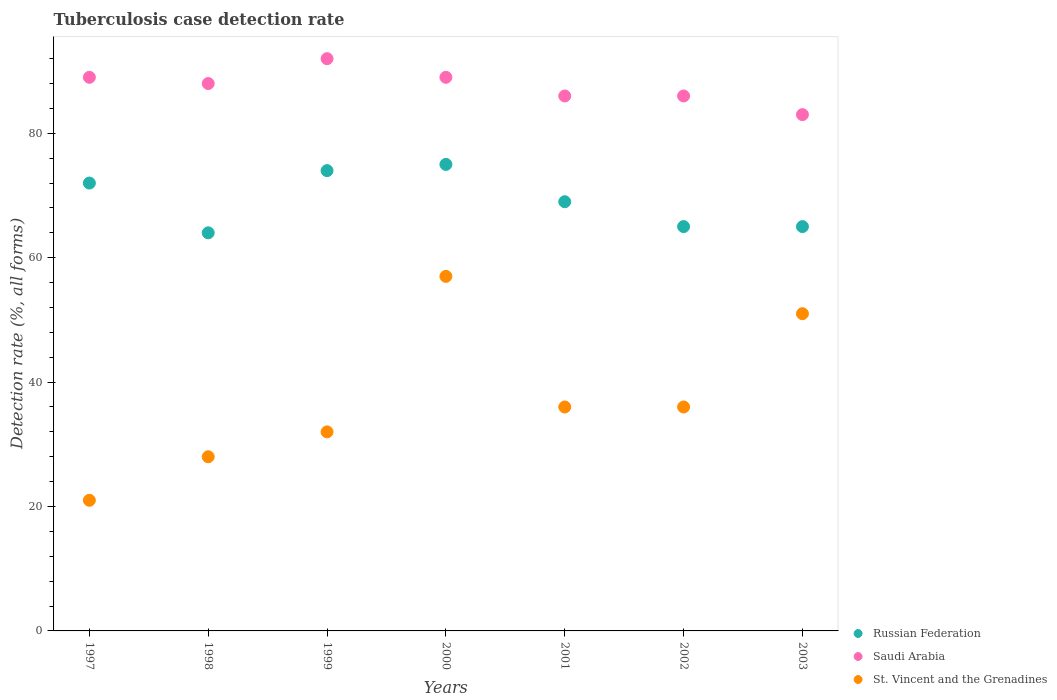Is the number of dotlines equal to the number of legend labels?
Offer a very short reply. Yes. What is the tuberculosis case detection rate in in Saudi Arabia in 2002?
Provide a short and direct response. 86. Across all years, what is the maximum tuberculosis case detection rate in in Saudi Arabia?
Your answer should be very brief. 92. Across all years, what is the minimum tuberculosis case detection rate in in Russian Federation?
Your answer should be compact. 64. In which year was the tuberculosis case detection rate in in Saudi Arabia maximum?
Make the answer very short. 1999. In which year was the tuberculosis case detection rate in in Saudi Arabia minimum?
Give a very brief answer. 2003. What is the total tuberculosis case detection rate in in St. Vincent and the Grenadines in the graph?
Give a very brief answer. 261. What is the average tuberculosis case detection rate in in Russian Federation per year?
Provide a short and direct response. 69.14. What is the ratio of the tuberculosis case detection rate in in Saudi Arabia in 1997 to that in 2003?
Provide a succinct answer. 1.07. Is the tuberculosis case detection rate in in St. Vincent and the Grenadines in 1997 less than that in 2003?
Your response must be concise. Yes. Is the sum of the tuberculosis case detection rate in in Saudi Arabia in 1998 and 2002 greater than the maximum tuberculosis case detection rate in in Russian Federation across all years?
Your answer should be very brief. Yes. Is it the case that in every year, the sum of the tuberculosis case detection rate in in Russian Federation and tuberculosis case detection rate in in Saudi Arabia  is greater than the tuberculosis case detection rate in in St. Vincent and the Grenadines?
Offer a very short reply. Yes. Does the tuberculosis case detection rate in in Saudi Arabia monotonically increase over the years?
Ensure brevity in your answer.  No. Is the tuberculosis case detection rate in in St. Vincent and the Grenadines strictly less than the tuberculosis case detection rate in in Russian Federation over the years?
Make the answer very short. Yes. How many dotlines are there?
Offer a very short reply. 3. How many years are there in the graph?
Ensure brevity in your answer.  7. What is the difference between two consecutive major ticks on the Y-axis?
Keep it short and to the point. 20. How many legend labels are there?
Offer a very short reply. 3. What is the title of the graph?
Offer a very short reply. Tuberculosis case detection rate. What is the label or title of the X-axis?
Your response must be concise. Years. What is the label or title of the Y-axis?
Provide a succinct answer. Detection rate (%, all forms). What is the Detection rate (%, all forms) of Russian Federation in 1997?
Provide a short and direct response. 72. What is the Detection rate (%, all forms) of Saudi Arabia in 1997?
Your answer should be very brief. 89. What is the Detection rate (%, all forms) in St. Vincent and the Grenadines in 1997?
Keep it short and to the point. 21. What is the Detection rate (%, all forms) in Russian Federation in 1998?
Make the answer very short. 64. What is the Detection rate (%, all forms) of Saudi Arabia in 1998?
Your answer should be compact. 88. What is the Detection rate (%, all forms) of St. Vincent and the Grenadines in 1998?
Your answer should be compact. 28. What is the Detection rate (%, all forms) of Saudi Arabia in 1999?
Provide a succinct answer. 92. What is the Detection rate (%, all forms) in St. Vincent and the Grenadines in 1999?
Your answer should be very brief. 32. What is the Detection rate (%, all forms) in Russian Federation in 2000?
Provide a succinct answer. 75. What is the Detection rate (%, all forms) in Saudi Arabia in 2000?
Ensure brevity in your answer.  89. What is the Detection rate (%, all forms) in St. Vincent and the Grenadines in 2001?
Offer a very short reply. 36. What is the Detection rate (%, all forms) in Saudi Arabia in 2002?
Your answer should be compact. 86. What is the Detection rate (%, all forms) of Russian Federation in 2003?
Ensure brevity in your answer.  65. What is the Detection rate (%, all forms) of Saudi Arabia in 2003?
Provide a short and direct response. 83. Across all years, what is the maximum Detection rate (%, all forms) in Saudi Arabia?
Offer a terse response. 92. What is the total Detection rate (%, all forms) of Russian Federation in the graph?
Your answer should be compact. 484. What is the total Detection rate (%, all forms) in Saudi Arabia in the graph?
Provide a succinct answer. 613. What is the total Detection rate (%, all forms) in St. Vincent and the Grenadines in the graph?
Give a very brief answer. 261. What is the difference between the Detection rate (%, all forms) in St. Vincent and the Grenadines in 1997 and that in 1998?
Make the answer very short. -7. What is the difference between the Detection rate (%, all forms) in Saudi Arabia in 1997 and that in 1999?
Provide a succinct answer. -3. What is the difference between the Detection rate (%, all forms) of St. Vincent and the Grenadines in 1997 and that in 1999?
Offer a terse response. -11. What is the difference between the Detection rate (%, all forms) in Russian Federation in 1997 and that in 2000?
Offer a terse response. -3. What is the difference between the Detection rate (%, all forms) of St. Vincent and the Grenadines in 1997 and that in 2000?
Offer a very short reply. -36. What is the difference between the Detection rate (%, all forms) in Russian Federation in 1997 and that in 2001?
Ensure brevity in your answer.  3. What is the difference between the Detection rate (%, all forms) of St. Vincent and the Grenadines in 1997 and that in 2001?
Offer a very short reply. -15. What is the difference between the Detection rate (%, all forms) in Russian Federation in 1997 and that in 2002?
Your response must be concise. 7. What is the difference between the Detection rate (%, all forms) of Saudi Arabia in 1997 and that in 2002?
Your answer should be compact. 3. What is the difference between the Detection rate (%, all forms) in St. Vincent and the Grenadines in 1997 and that in 2002?
Give a very brief answer. -15. What is the difference between the Detection rate (%, all forms) in Russian Federation in 1997 and that in 2003?
Give a very brief answer. 7. What is the difference between the Detection rate (%, all forms) of St. Vincent and the Grenadines in 1997 and that in 2003?
Ensure brevity in your answer.  -30. What is the difference between the Detection rate (%, all forms) in St. Vincent and the Grenadines in 1998 and that in 1999?
Keep it short and to the point. -4. What is the difference between the Detection rate (%, all forms) in Russian Federation in 1998 and that in 2000?
Your answer should be compact. -11. What is the difference between the Detection rate (%, all forms) in St. Vincent and the Grenadines in 1998 and that in 2000?
Your answer should be compact. -29. What is the difference between the Detection rate (%, all forms) of Russian Federation in 1998 and that in 2002?
Your answer should be very brief. -1. What is the difference between the Detection rate (%, all forms) of St. Vincent and the Grenadines in 1998 and that in 2002?
Make the answer very short. -8. What is the difference between the Detection rate (%, all forms) in Russian Federation in 1998 and that in 2003?
Ensure brevity in your answer.  -1. What is the difference between the Detection rate (%, all forms) in St. Vincent and the Grenadines in 1999 and that in 2000?
Keep it short and to the point. -25. What is the difference between the Detection rate (%, all forms) in Russian Federation in 1999 and that in 2001?
Your answer should be compact. 5. What is the difference between the Detection rate (%, all forms) in Saudi Arabia in 1999 and that in 2001?
Provide a succinct answer. 6. What is the difference between the Detection rate (%, all forms) in St. Vincent and the Grenadines in 1999 and that in 2001?
Ensure brevity in your answer.  -4. What is the difference between the Detection rate (%, all forms) of Russian Federation in 1999 and that in 2002?
Your answer should be very brief. 9. What is the difference between the Detection rate (%, all forms) in St. Vincent and the Grenadines in 1999 and that in 2003?
Provide a short and direct response. -19. What is the difference between the Detection rate (%, all forms) of Saudi Arabia in 2000 and that in 2001?
Offer a very short reply. 3. What is the difference between the Detection rate (%, all forms) in Russian Federation in 2001 and that in 2002?
Give a very brief answer. 4. What is the difference between the Detection rate (%, all forms) in Russian Federation in 2002 and that in 2003?
Give a very brief answer. 0. What is the difference between the Detection rate (%, all forms) in Russian Federation in 1997 and the Detection rate (%, all forms) in St. Vincent and the Grenadines in 1998?
Keep it short and to the point. 44. What is the difference between the Detection rate (%, all forms) in Saudi Arabia in 1997 and the Detection rate (%, all forms) in St. Vincent and the Grenadines in 1998?
Provide a succinct answer. 61. What is the difference between the Detection rate (%, all forms) in Russian Federation in 1997 and the Detection rate (%, all forms) in St. Vincent and the Grenadines in 1999?
Offer a terse response. 40. What is the difference between the Detection rate (%, all forms) of Saudi Arabia in 1997 and the Detection rate (%, all forms) of St. Vincent and the Grenadines in 2000?
Offer a very short reply. 32. What is the difference between the Detection rate (%, all forms) of Russian Federation in 1997 and the Detection rate (%, all forms) of Saudi Arabia in 2001?
Make the answer very short. -14. What is the difference between the Detection rate (%, all forms) in Saudi Arabia in 1997 and the Detection rate (%, all forms) in St. Vincent and the Grenadines in 2001?
Make the answer very short. 53. What is the difference between the Detection rate (%, all forms) in Saudi Arabia in 1997 and the Detection rate (%, all forms) in St. Vincent and the Grenadines in 2002?
Provide a short and direct response. 53. What is the difference between the Detection rate (%, all forms) of Russian Federation in 1997 and the Detection rate (%, all forms) of Saudi Arabia in 2003?
Offer a very short reply. -11. What is the difference between the Detection rate (%, all forms) in Russian Federation in 1997 and the Detection rate (%, all forms) in St. Vincent and the Grenadines in 2003?
Offer a very short reply. 21. What is the difference between the Detection rate (%, all forms) in Russian Federation in 1998 and the Detection rate (%, all forms) in Saudi Arabia in 1999?
Provide a succinct answer. -28. What is the difference between the Detection rate (%, all forms) in Russian Federation in 1998 and the Detection rate (%, all forms) in St. Vincent and the Grenadines in 2000?
Offer a very short reply. 7. What is the difference between the Detection rate (%, all forms) of Russian Federation in 1998 and the Detection rate (%, all forms) of St. Vincent and the Grenadines in 2001?
Give a very brief answer. 28. What is the difference between the Detection rate (%, all forms) of Saudi Arabia in 1998 and the Detection rate (%, all forms) of St. Vincent and the Grenadines in 2001?
Your response must be concise. 52. What is the difference between the Detection rate (%, all forms) in Russian Federation in 1998 and the Detection rate (%, all forms) in St. Vincent and the Grenadines in 2002?
Provide a short and direct response. 28. What is the difference between the Detection rate (%, all forms) in Saudi Arabia in 1998 and the Detection rate (%, all forms) in St. Vincent and the Grenadines in 2002?
Keep it short and to the point. 52. What is the difference between the Detection rate (%, all forms) of Saudi Arabia in 1998 and the Detection rate (%, all forms) of St. Vincent and the Grenadines in 2003?
Ensure brevity in your answer.  37. What is the difference between the Detection rate (%, all forms) in Russian Federation in 1999 and the Detection rate (%, all forms) in St. Vincent and the Grenadines in 2000?
Offer a very short reply. 17. What is the difference between the Detection rate (%, all forms) in Saudi Arabia in 1999 and the Detection rate (%, all forms) in St. Vincent and the Grenadines in 2001?
Make the answer very short. 56. What is the difference between the Detection rate (%, all forms) in Russian Federation in 1999 and the Detection rate (%, all forms) in Saudi Arabia in 2002?
Provide a short and direct response. -12. What is the difference between the Detection rate (%, all forms) of Russian Federation in 1999 and the Detection rate (%, all forms) of Saudi Arabia in 2003?
Keep it short and to the point. -9. What is the difference between the Detection rate (%, all forms) in Russian Federation in 1999 and the Detection rate (%, all forms) in St. Vincent and the Grenadines in 2003?
Ensure brevity in your answer.  23. What is the difference between the Detection rate (%, all forms) in Saudi Arabia in 1999 and the Detection rate (%, all forms) in St. Vincent and the Grenadines in 2003?
Provide a succinct answer. 41. What is the difference between the Detection rate (%, all forms) in Russian Federation in 2000 and the Detection rate (%, all forms) in Saudi Arabia in 2001?
Your response must be concise. -11. What is the difference between the Detection rate (%, all forms) of Russian Federation in 2000 and the Detection rate (%, all forms) of Saudi Arabia in 2002?
Keep it short and to the point. -11. What is the difference between the Detection rate (%, all forms) in Russian Federation in 2000 and the Detection rate (%, all forms) in Saudi Arabia in 2003?
Your answer should be compact. -8. What is the difference between the Detection rate (%, all forms) in Russian Federation in 2000 and the Detection rate (%, all forms) in St. Vincent and the Grenadines in 2003?
Keep it short and to the point. 24. What is the difference between the Detection rate (%, all forms) of Saudi Arabia in 2000 and the Detection rate (%, all forms) of St. Vincent and the Grenadines in 2003?
Make the answer very short. 38. What is the difference between the Detection rate (%, all forms) of Russian Federation in 2001 and the Detection rate (%, all forms) of Saudi Arabia in 2002?
Give a very brief answer. -17. What is the difference between the Detection rate (%, all forms) in Saudi Arabia in 2001 and the Detection rate (%, all forms) in St. Vincent and the Grenadines in 2002?
Offer a terse response. 50. What is the difference between the Detection rate (%, all forms) in Russian Federation in 2001 and the Detection rate (%, all forms) in Saudi Arabia in 2003?
Keep it short and to the point. -14. What is the difference between the Detection rate (%, all forms) of Russian Federation in 2001 and the Detection rate (%, all forms) of St. Vincent and the Grenadines in 2003?
Give a very brief answer. 18. What is the difference between the Detection rate (%, all forms) in Russian Federation in 2002 and the Detection rate (%, all forms) in Saudi Arabia in 2003?
Offer a terse response. -18. What is the difference between the Detection rate (%, all forms) in Russian Federation in 2002 and the Detection rate (%, all forms) in St. Vincent and the Grenadines in 2003?
Provide a short and direct response. 14. What is the average Detection rate (%, all forms) in Russian Federation per year?
Provide a short and direct response. 69.14. What is the average Detection rate (%, all forms) of Saudi Arabia per year?
Offer a very short reply. 87.57. What is the average Detection rate (%, all forms) of St. Vincent and the Grenadines per year?
Ensure brevity in your answer.  37.29. In the year 1997, what is the difference between the Detection rate (%, all forms) of Russian Federation and Detection rate (%, all forms) of St. Vincent and the Grenadines?
Provide a succinct answer. 51. In the year 1997, what is the difference between the Detection rate (%, all forms) of Saudi Arabia and Detection rate (%, all forms) of St. Vincent and the Grenadines?
Make the answer very short. 68. In the year 1999, what is the difference between the Detection rate (%, all forms) of Russian Federation and Detection rate (%, all forms) of Saudi Arabia?
Keep it short and to the point. -18. In the year 2000, what is the difference between the Detection rate (%, all forms) in Russian Federation and Detection rate (%, all forms) in Saudi Arabia?
Make the answer very short. -14. In the year 2000, what is the difference between the Detection rate (%, all forms) of Russian Federation and Detection rate (%, all forms) of St. Vincent and the Grenadines?
Your answer should be compact. 18. In the year 2001, what is the difference between the Detection rate (%, all forms) of Russian Federation and Detection rate (%, all forms) of Saudi Arabia?
Offer a very short reply. -17. In the year 2001, what is the difference between the Detection rate (%, all forms) in Russian Federation and Detection rate (%, all forms) in St. Vincent and the Grenadines?
Ensure brevity in your answer.  33. In the year 2001, what is the difference between the Detection rate (%, all forms) of Saudi Arabia and Detection rate (%, all forms) of St. Vincent and the Grenadines?
Your response must be concise. 50. In the year 2002, what is the difference between the Detection rate (%, all forms) in Russian Federation and Detection rate (%, all forms) in Saudi Arabia?
Keep it short and to the point. -21. In the year 2002, what is the difference between the Detection rate (%, all forms) in Saudi Arabia and Detection rate (%, all forms) in St. Vincent and the Grenadines?
Your answer should be compact. 50. In the year 2003, what is the difference between the Detection rate (%, all forms) of Russian Federation and Detection rate (%, all forms) of St. Vincent and the Grenadines?
Make the answer very short. 14. What is the ratio of the Detection rate (%, all forms) in Saudi Arabia in 1997 to that in 1998?
Make the answer very short. 1.01. What is the ratio of the Detection rate (%, all forms) in St. Vincent and the Grenadines in 1997 to that in 1998?
Offer a terse response. 0.75. What is the ratio of the Detection rate (%, all forms) in Saudi Arabia in 1997 to that in 1999?
Provide a short and direct response. 0.97. What is the ratio of the Detection rate (%, all forms) of St. Vincent and the Grenadines in 1997 to that in 1999?
Offer a terse response. 0.66. What is the ratio of the Detection rate (%, all forms) of Russian Federation in 1997 to that in 2000?
Give a very brief answer. 0.96. What is the ratio of the Detection rate (%, all forms) of St. Vincent and the Grenadines in 1997 to that in 2000?
Offer a terse response. 0.37. What is the ratio of the Detection rate (%, all forms) of Russian Federation in 1997 to that in 2001?
Provide a succinct answer. 1.04. What is the ratio of the Detection rate (%, all forms) of Saudi Arabia in 1997 to that in 2001?
Your response must be concise. 1.03. What is the ratio of the Detection rate (%, all forms) in St. Vincent and the Grenadines in 1997 to that in 2001?
Your answer should be very brief. 0.58. What is the ratio of the Detection rate (%, all forms) in Russian Federation in 1997 to that in 2002?
Make the answer very short. 1.11. What is the ratio of the Detection rate (%, all forms) in Saudi Arabia in 1997 to that in 2002?
Provide a succinct answer. 1.03. What is the ratio of the Detection rate (%, all forms) of St. Vincent and the Grenadines in 1997 to that in 2002?
Your answer should be very brief. 0.58. What is the ratio of the Detection rate (%, all forms) of Russian Federation in 1997 to that in 2003?
Provide a succinct answer. 1.11. What is the ratio of the Detection rate (%, all forms) in Saudi Arabia in 1997 to that in 2003?
Provide a succinct answer. 1.07. What is the ratio of the Detection rate (%, all forms) of St. Vincent and the Grenadines in 1997 to that in 2003?
Offer a very short reply. 0.41. What is the ratio of the Detection rate (%, all forms) of Russian Federation in 1998 to that in 1999?
Ensure brevity in your answer.  0.86. What is the ratio of the Detection rate (%, all forms) of Saudi Arabia in 1998 to that in 1999?
Provide a succinct answer. 0.96. What is the ratio of the Detection rate (%, all forms) of St. Vincent and the Grenadines in 1998 to that in 1999?
Provide a short and direct response. 0.88. What is the ratio of the Detection rate (%, all forms) in Russian Federation in 1998 to that in 2000?
Your answer should be very brief. 0.85. What is the ratio of the Detection rate (%, all forms) in Saudi Arabia in 1998 to that in 2000?
Your answer should be very brief. 0.99. What is the ratio of the Detection rate (%, all forms) in St. Vincent and the Grenadines in 1998 to that in 2000?
Give a very brief answer. 0.49. What is the ratio of the Detection rate (%, all forms) of Russian Federation in 1998 to that in 2001?
Ensure brevity in your answer.  0.93. What is the ratio of the Detection rate (%, all forms) in Saudi Arabia in 1998 to that in 2001?
Ensure brevity in your answer.  1.02. What is the ratio of the Detection rate (%, all forms) in St. Vincent and the Grenadines in 1998 to that in 2001?
Your answer should be very brief. 0.78. What is the ratio of the Detection rate (%, all forms) of Russian Federation in 1998 to that in 2002?
Offer a very short reply. 0.98. What is the ratio of the Detection rate (%, all forms) of Saudi Arabia in 1998 to that in 2002?
Provide a succinct answer. 1.02. What is the ratio of the Detection rate (%, all forms) of St. Vincent and the Grenadines in 1998 to that in 2002?
Give a very brief answer. 0.78. What is the ratio of the Detection rate (%, all forms) of Russian Federation in 1998 to that in 2003?
Give a very brief answer. 0.98. What is the ratio of the Detection rate (%, all forms) in Saudi Arabia in 1998 to that in 2003?
Offer a very short reply. 1.06. What is the ratio of the Detection rate (%, all forms) of St. Vincent and the Grenadines in 1998 to that in 2003?
Make the answer very short. 0.55. What is the ratio of the Detection rate (%, all forms) in Russian Federation in 1999 to that in 2000?
Provide a succinct answer. 0.99. What is the ratio of the Detection rate (%, all forms) in Saudi Arabia in 1999 to that in 2000?
Offer a terse response. 1.03. What is the ratio of the Detection rate (%, all forms) of St. Vincent and the Grenadines in 1999 to that in 2000?
Your answer should be very brief. 0.56. What is the ratio of the Detection rate (%, all forms) of Russian Federation in 1999 to that in 2001?
Ensure brevity in your answer.  1.07. What is the ratio of the Detection rate (%, all forms) of Saudi Arabia in 1999 to that in 2001?
Make the answer very short. 1.07. What is the ratio of the Detection rate (%, all forms) of St. Vincent and the Grenadines in 1999 to that in 2001?
Keep it short and to the point. 0.89. What is the ratio of the Detection rate (%, all forms) of Russian Federation in 1999 to that in 2002?
Ensure brevity in your answer.  1.14. What is the ratio of the Detection rate (%, all forms) of Saudi Arabia in 1999 to that in 2002?
Your response must be concise. 1.07. What is the ratio of the Detection rate (%, all forms) of St. Vincent and the Grenadines in 1999 to that in 2002?
Your answer should be very brief. 0.89. What is the ratio of the Detection rate (%, all forms) in Russian Federation in 1999 to that in 2003?
Make the answer very short. 1.14. What is the ratio of the Detection rate (%, all forms) in Saudi Arabia in 1999 to that in 2003?
Provide a succinct answer. 1.11. What is the ratio of the Detection rate (%, all forms) of St. Vincent and the Grenadines in 1999 to that in 2003?
Make the answer very short. 0.63. What is the ratio of the Detection rate (%, all forms) in Russian Federation in 2000 to that in 2001?
Provide a short and direct response. 1.09. What is the ratio of the Detection rate (%, all forms) of Saudi Arabia in 2000 to that in 2001?
Offer a terse response. 1.03. What is the ratio of the Detection rate (%, all forms) of St. Vincent and the Grenadines in 2000 to that in 2001?
Your answer should be very brief. 1.58. What is the ratio of the Detection rate (%, all forms) in Russian Federation in 2000 to that in 2002?
Offer a very short reply. 1.15. What is the ratio of the Detection rate (%, all forms) of Saudi Arabia in 2000 to that in 2002?
Your answer should be compact. 1.03. What is the ratio of the Detection rate (%, all forms) in St. Vincent and the Grenadines in 2000 to that in 2002?
Offer a very short reply. 1.58. What is the ratio of the Detection rate (%, all forms) in Russian Federation in 2000 to that in 2003?
Provide a succinct answer. 1.15. What is the ratio of the Detection rate (%, all forms) of Saudi Arabia in 2000 to that in 2003?
Ensure brevity in your answer.  1.07. What is the ratio of the Detection rate (%, all forms) of St. Vincent and the Grenadines in 2000 to that in 2003?
Offer a terse response. 1.12. What is the ratio of the Detection rate (%, all forms) in Russian Federation in 2001 to that in 2002?
Keep it short and to the point. 1.06. What is the ratio of the Detection rate (%, all forms) in Saudi Arabia in 2001 to that in 2002?
Your response must be concise. 1. What is the ratio of the Detection rate (%, all forms) of Russian Federation in 2001 to that in 2003?
Ensure brevity in your answer.  1.06. What is the ratio of the Detection rate (%, all forms) of Saudi Arabia in 2001 to that in 2003?
Your answer should be compact. 1.04. What is the ratio of the Detection rate (%, all forms) of St. Vincent and the Grenadines in 2001 to that in 2003?
Offer a terse response. 0.71. What is the ratio of the Detection rate (%, all forms) of Saudi Arabia in 2002 to that in 2003?
Ensure brevity in your answer.  1.04. What is the ratio of the Detection rate (%, all forms) in St. Vincent and the Grenadines in 2002 to that in 2003?
Offer a terse response. 0.71. What is the difference between the highest and the second highest Detection rate (%, all forms) of St. Vincent and the Grenadines?
Make the answer very short. 6. What is the difference between the highest and the lowest Detection rate (%, all forms) in Russian Federation?
Your response must be concise. 11. What is the difference between the highest and the lowest Detection rate (%, all forms) in St. Vincent and the Grenadines?
Provide a succinct answer. 36. 